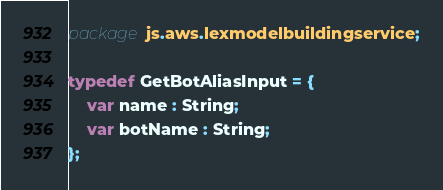Convert code to text. <code><loc_0><loc_0><loc_500><loc_500><_Haxe_>package js.aws.lexmodelbuildingservice;

typedef GetBotAliasInput = {
    var name : String;
    var botName : String;
};
</code> 